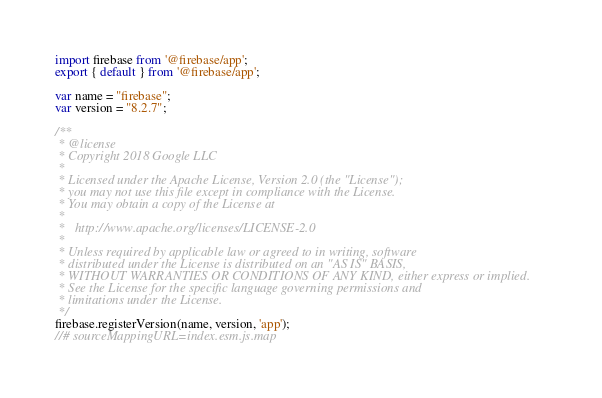<code> <loc_0><loc_0><loc_500><loc_500><_JavaScript_>import firebase from '@firebase/app';
export { default } from '@firebase/app';

var name = "firebase";
var version = "8.2.7";

/**
 * @license
 * Copyright 2018 Google LLC
 *
 * Licensed under the Apache License, Version 2.0 (the "License");
 * you may not use this file except in compliance with the License.
 * You may obtain a copy of the License at
 *
 *   http://www.apache.org/licenses/LICENSE-2.0
 *
 * Unless required by applicable law or agreed to in writing, software
 * distributed under the License is distributed on an "AS IS" BASIS,
 * WITHOUT WARRANTIES OR CONDITIONS OF ANY KIND, either express or implied.
 * See the License for the specific language governing permissions and
 * limitations under the License.
 */
firebase.registerVersion(name, version, 'app');
//# sourceMappingURL=index.esm.js.map
</code> 